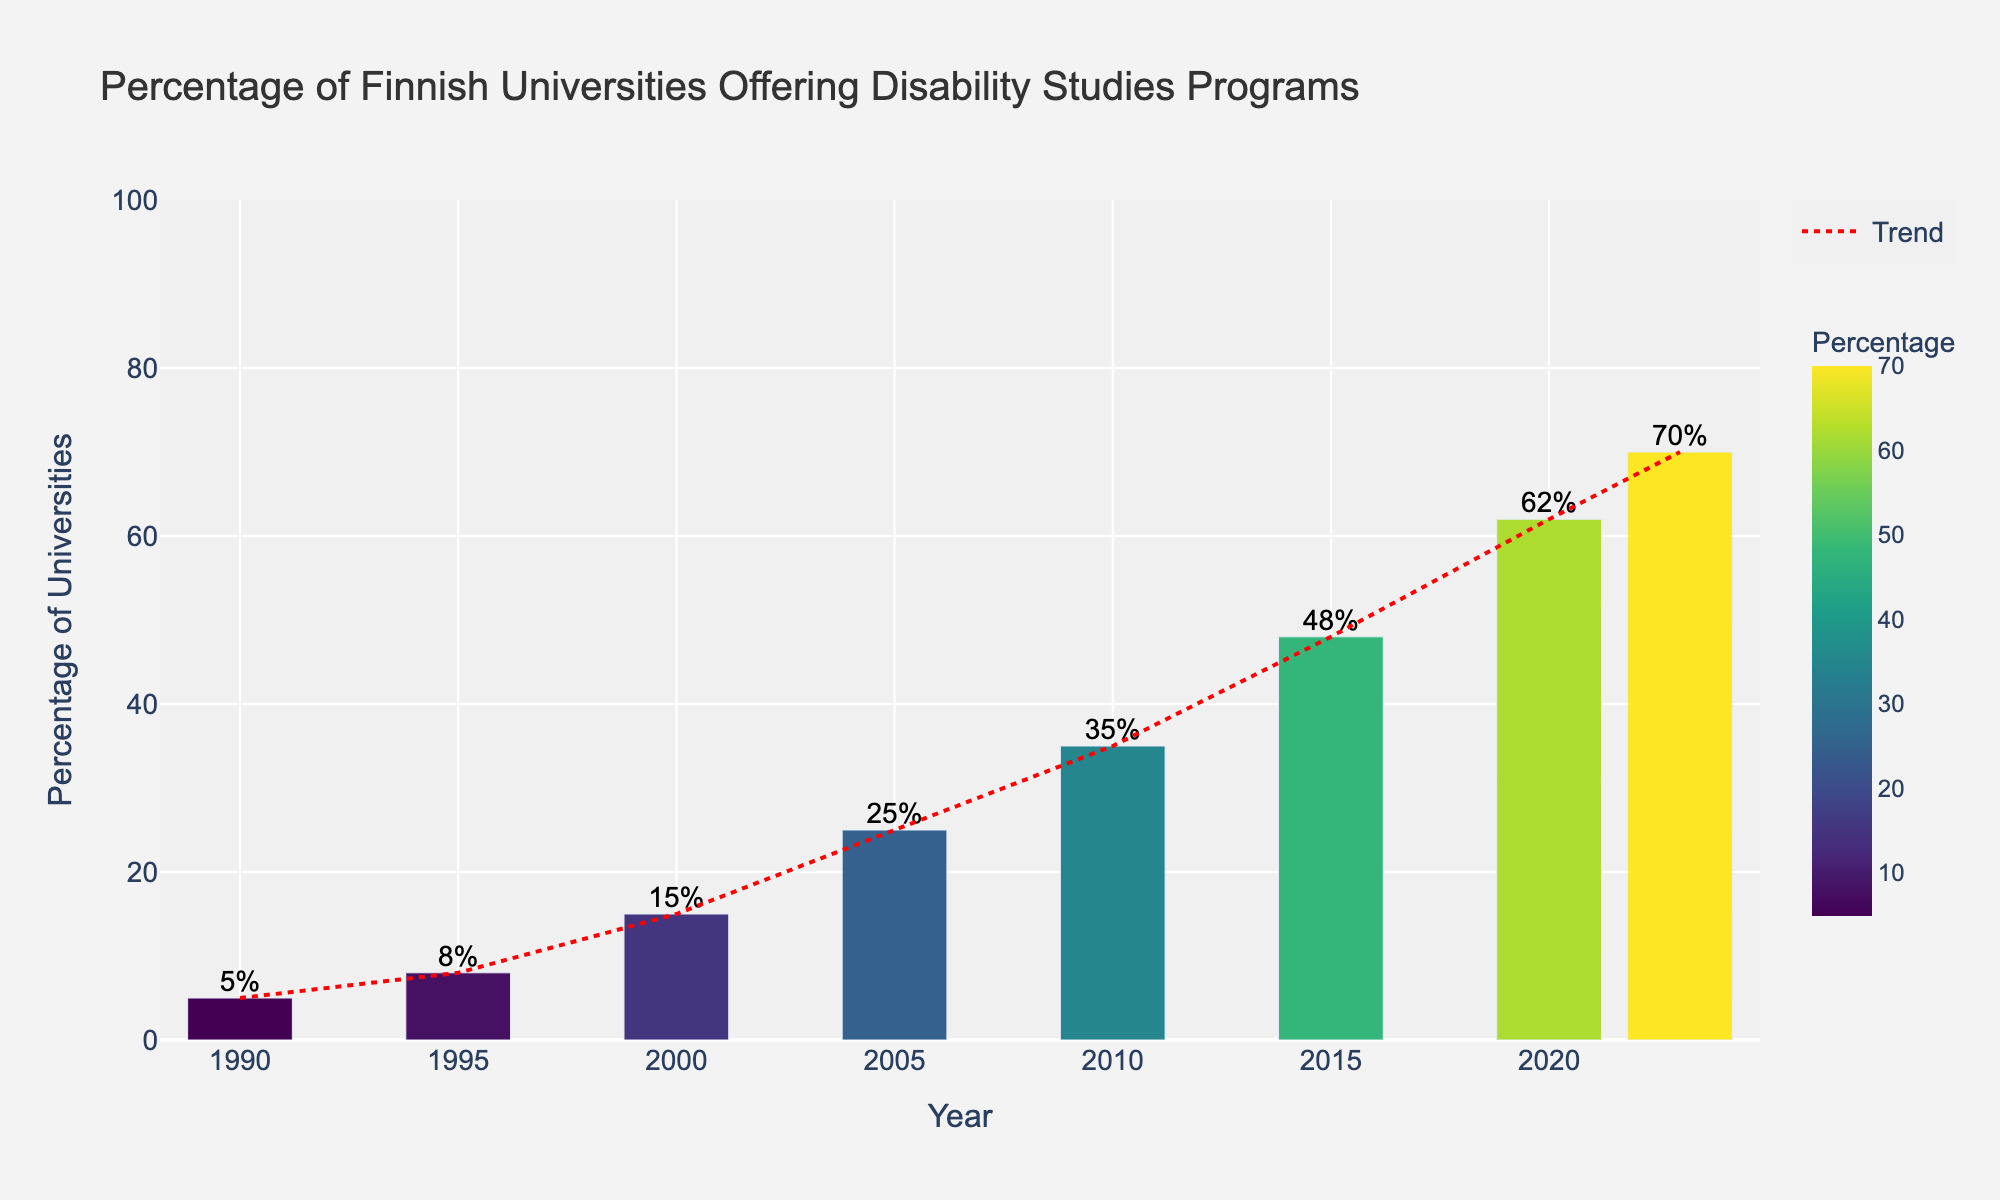What was the percentage of Finnish universities offering disability studies programs in 2000? Look at the bar corresponding to the year 2000 on the x-axis, and observe the height of the bar which represents the percentage. The label on top of the bar also indicates this value.
Answer: 15% How many percentage points did the percentage of universities offering disability studies programs increase from 1990 to 2023? Subtract the percentage in 1990 from the percentage in 2023: 70% - 5% = 65%. This shows the increase in percentage points.
Answer: 65% In which decade did the percentage of universities offering disability studies programs see the highest increase? Compare the differences for each decade: from 1990 to 2000 (+10%), from 2000 to 2010 (+20%), and from 2010 to 2020 (+27%). The highest increase happens in the third interval, from 2010 to 2020.
Answer: 2010-2020 Which year saw a higher percentage of universities offering disability studies programs: 2005 or 2015? Compare the heights of the bars for the years 2005 and 2015. The bar for 2015 is higher than for 2005.
Answer: 2015 What is the average percentage of universities offering disability studies programs from 1990 to 2023? Sum the percentages for each year (5+8+15+25+35+48+62+70 = 268) and divide by the number of years (8). The average percentage is 268/8 = 33.5%.
Answer: 33.5% Did the percentage of universities offering disability studies programs ever decrease over the years shown? Examine the trend line and the heights of the bars from year to year. All bars increase or stay the same from one year to the next.
Answer: No By how many percentage points did the percentage of universities offering disability studies programs increase during the 21st century (2000 to 2023)? Subtract the percentage in 2000 from the percentage in 2023: 70% - 15% = 55%. This represents the increase in the 21st century.
Answer: 55% Which color on the bar chart indicates the highest percentage, and in which year does this occur? The darkest color on the color scale indicates the highest percentage. The year with the highest percentage (70%) is 2023, which is colored the darkest.
Answer: Darkest color, 2023 How does the trend line in the chart visually represent the overall trend from 1990 to 2023? The trend line is a dashed red line moving upward from left to right, representing a general increase in the percentage of universities offering disability studies programs.
Answer: Upward trend When comparing the percentages in 2010 and 2020, what is the difference? Subtract the 2010 percentage from the 2020 percentage: 62% - 35% = 27%.
Answer: 27% 